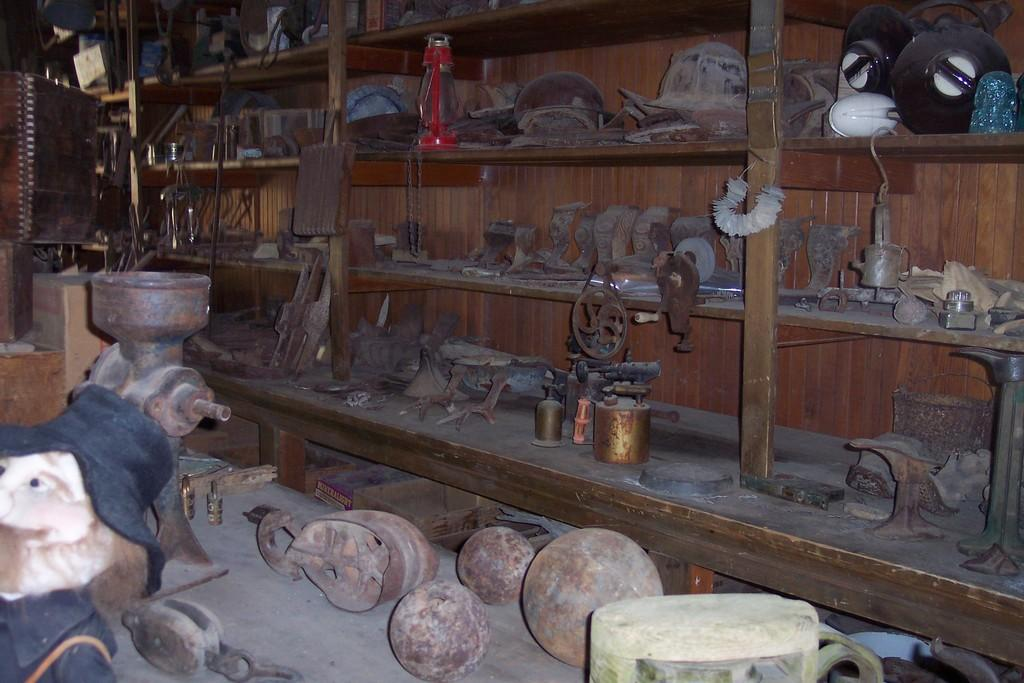What type of objects can be seen in the image? There are metal objects and a doll in the image. Where are the metal objects located? The metal objects are on racks in the image. What other objects are present on the racks? There are other objects in the racks besides the metal objects. What additional item can be seen in the image? There is a lantern in the image. What type of silk material is draped over the doll in the image? There is no silk material draped over the doll in the image; it is a doll made of a different material. What event is taking place in the image? There is no event depicted in the image; it is a still image of objects and a doll. 